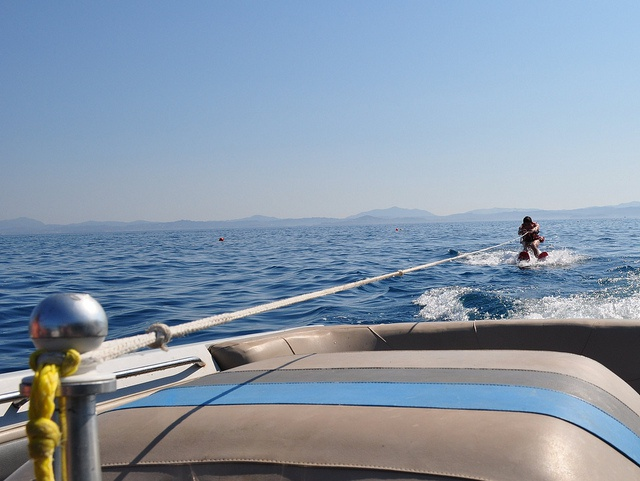Describe the objects in this image and their specific colors. I can see boat in gray, darkgray, and black tones and people in gray, black, maroon, and darkgray tones in this image. 